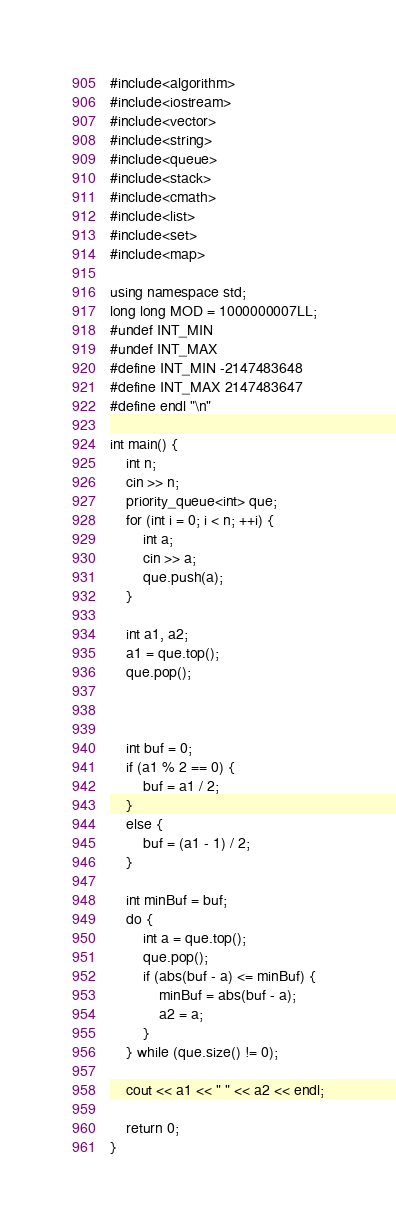<code> <loc_0><loc_0><loc_500><loc_500><_C++_>#include<algorithm>
#include<iostream>
#include<vector>
#include<string>
#include<queue>
#include<stack>
#include<cmath>
#include<list>
#include<set>
#include<map>

using namespace std;
long long MOD = 1000000007LL;
#undef INT_MIN
#undef INT_MAX
#define INT_MIN -2147483648
#define INT_MAX 2147483647
#define endl "\n"

int main() {
	int n;
    cin >> n;
	priority_queue<int> que;
	for (int i = 0; i < n; ++i) {
		int a;
		cin >> a;
		que.push(a);
	}

    int a1, a2;
    a1 = que.top();
    que.pop();



	int buf = 0;
	if (a1 % 2 == 0) {
		buf = a1 / 2;
	}
	else {
		buf = (a1 - 1) / 2;
	}

	int minBuf = buf;
	do {
		int a = que.top();
		que.pop();
		if (abs(buf - a) <= minBuf) {
			minBuf = abs(buf - a);
			a2 = a;
		}
	} while (que.size() != 0);

    cout << a1 << " " << a2 << endl;

	return 0;
}
</code> 